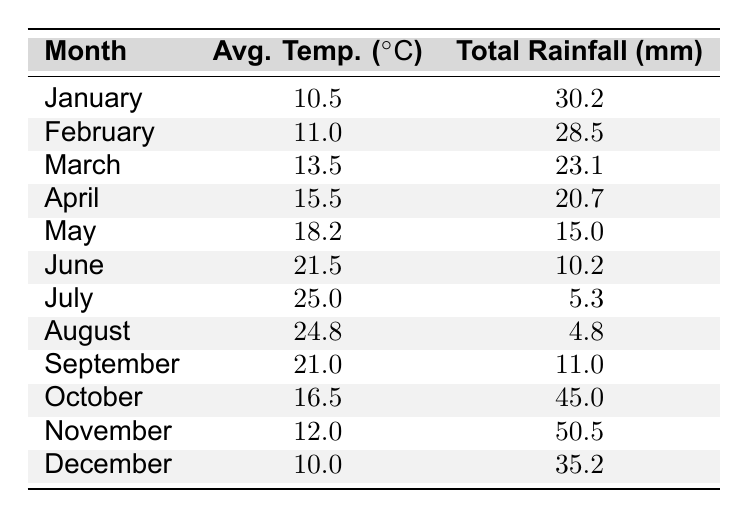What is the average temperature in July? The table shows the average temperature for July is 25.0 degrees Celsius.
Answer: 25.0 What was the total rainfall in April? According to the table, the total rainfall in April is 20.7 mm.
Answer: 20.7 Which month had the highest total rainfall? By inspecting the 'Total Rainfall' column, November has the highest value at 50.5 mm.
Answer: November Was the total rainfall in June less than in March? June's total rainfall is 10.2 mm, while March's is 23.1 mm; therefore, June had less rainfall than March.
Answer: Yes What is the average temperature for the first half of the year (January to June)? The average temperatures for the first six months are 10.5, 11.0, 13.5, 15.5, 18.2, and 21.5 degrees. Summing these gives 90.2, and dividing by 6 results in an average of 15.03 degrees.
Answer: 15.0 How much more total rainfall was there in October compared to July? October has 45.0 mm of rainfall, while July has 5.3 mm. The difference is 45.0 - 5.3 = 39.7 mm more in October.
Answer: 39.7 What is the median average temperature across all months? Listing the average temperatures: 10.0, 10.5, 11.0, 12.0, 13.5, 15.5, 18.2, 21.0, 21.5, 24.8, 25.0, we find the middle values (15.5 and 18.2) and average them: (15.5 + 18.2) / 2 = 16.85.
Answer: 16.9 Is the average temperature in December higher than in January? The average temperature in December is 10.0 degrees, and in January, it is 10.5 degrees, indicating December is not higher.
Answer: No Which month had the lowest average temperature? The lowest average temperature listed is in January at 10.5 degrees Celsius.
Answer: January What is the total rainfall in the second half of the year (July to December)? The total rainfall from July to December includes 5.3, 4.8, 11.0, 45.0, 50.5, and 35.2 mm. Summing these gives: 5.3 + 4.8 + 11.0 + 45.0 + 50.5 + 35.2 = 151.8 mm.
Answer: 151.8 